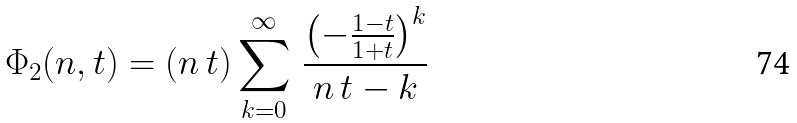<formula> <loc_0><loc_0><loc_500><loc_500>\Phi _ { 2 } ( n , t ) = ( n \, t ) \sum _ { k = 0 } ^ { \infty } \, \frac { \left ( - \frac { 1 - t } { 1 + t } \right ) ^ { k } } { n \, t - k }</formula> 